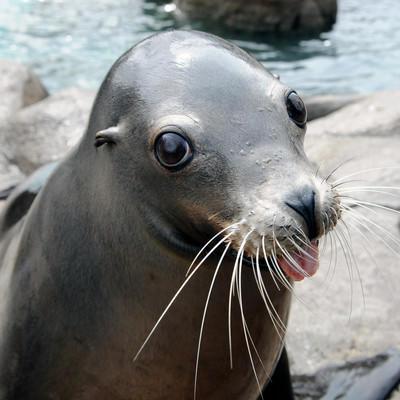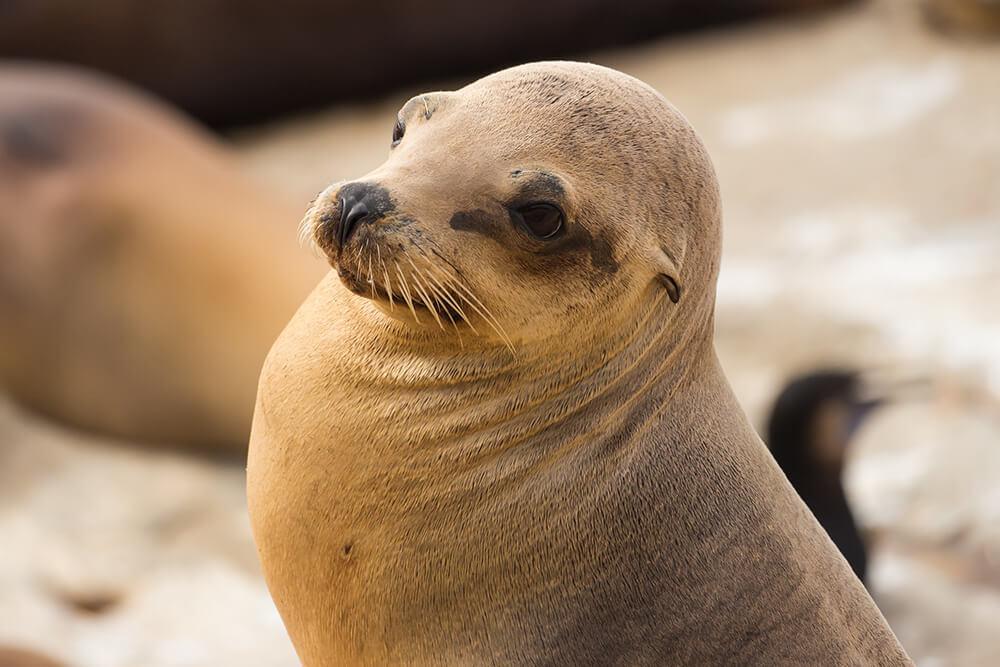The first image is the image on the left, the second image is the image on the right. Analyze the images presented: Is the assertion "The seal in the right image is facing right." valid? Answer yes or no. No. The first image is the image on the left, the second image is the image on the right. Examine the images to the left and right. Is the description "Three toes can be counted in the image on the left." accurate? Answer yes or no. No. The first image is the image on the left, the second image is the image on the right. Considering the images on both sides, is "There are two seals" valid? Answer yes or no. Yes. The first image is the image on the left, the second image is the image on the right. Assess this claim about the two images: "there are two seals in the image on the right.". Correct or not? Answer yes or no. Yes. 